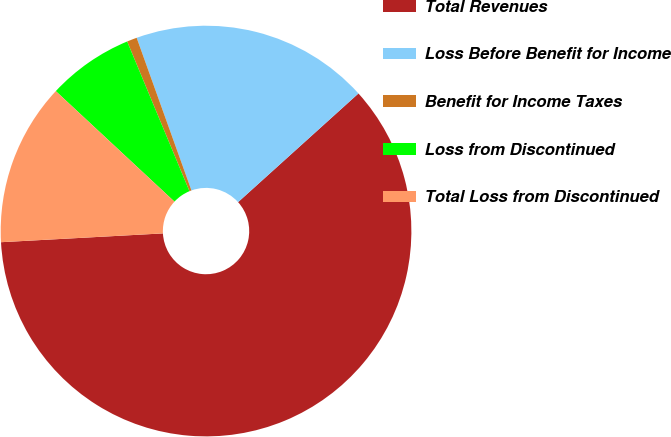<chart> <loc_0><loc_0><loc_500><loc_500><pie_chart><fcel>Total Revenues<fcel>Loss Before Benefit for Income<fcel>Benefit for Income Taxes<fcel>Loss from Discontinued<fcel>Total Loss from Discontinued<nl><fcel>60.83%<fcel>18.8%<fcel>0.79%<fcel>6.79%<fcel>12.8%<nl></chart> 